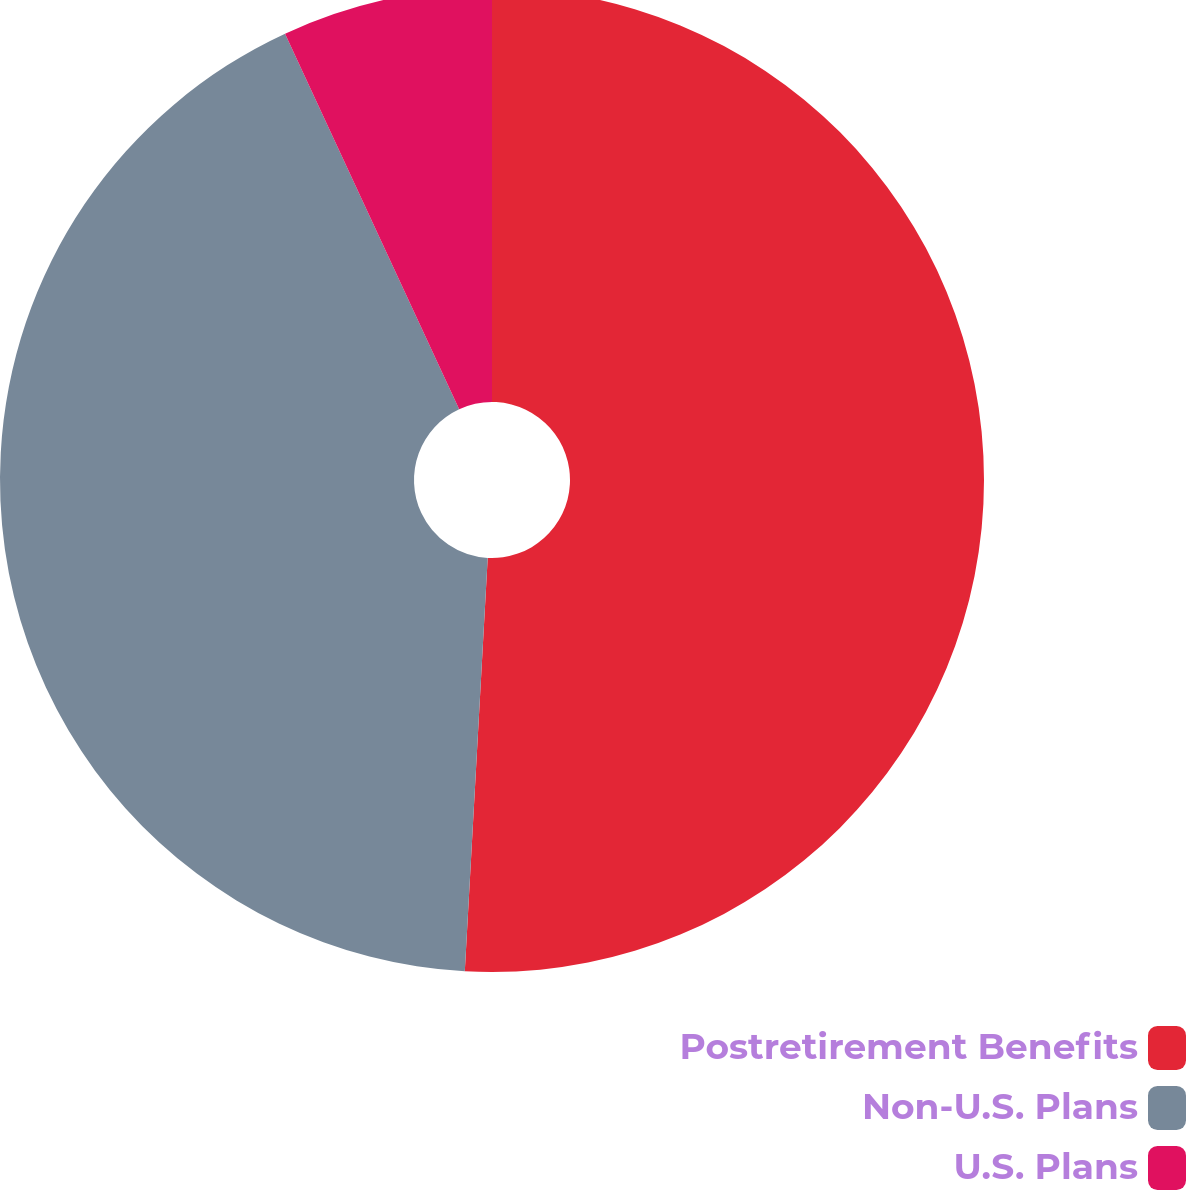Convert chart to OTSL. <chart><loc_0><loc_0><loc_500><loc_500><pie_chart><fcel>Postretirement Benefits<fcel>Non-U.S. Plans<fcel>U.S. Plans<nl><fcel>50.88%<fcel>42.21%<fcel>6.91%<nl></chart> 